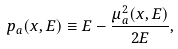Convert formula to latex. <formula><loc_0><loc_0><loc_500><loc_500>p _ { a } ( x , E ) \equiv E - \frac { \mu _ { a } ^ { 2 } ( x , E ) } { 2 E } ,</formula> 